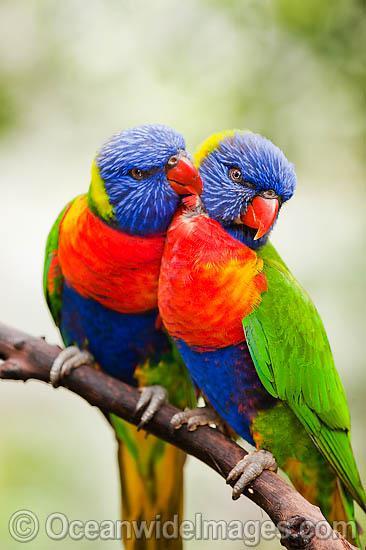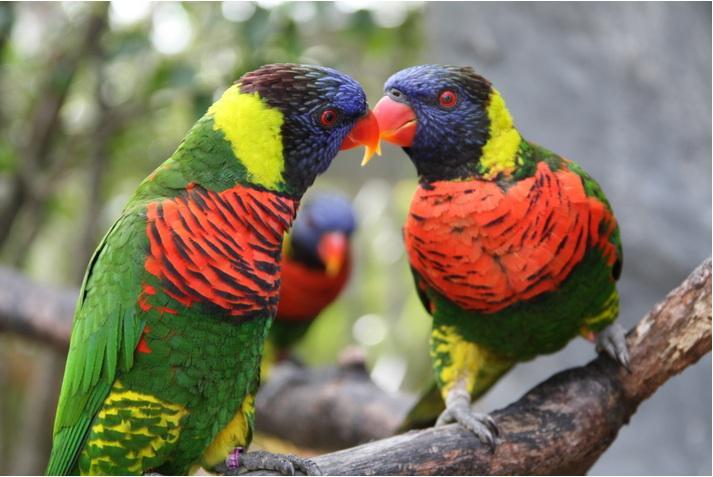The first image is the image on the left, the second image is the image on the right. Analyze the images presented: Is the assertion "A human hand is offering food to birds in the left image." valid? Answer yes or no. No. 